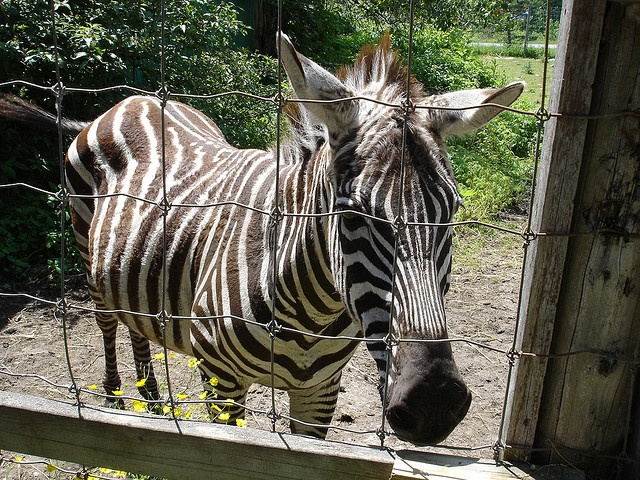Describe the objects in this image and their specific colors. I can see a zebra in darkgreen, black, gray, white, and darkgray tones in this image. 